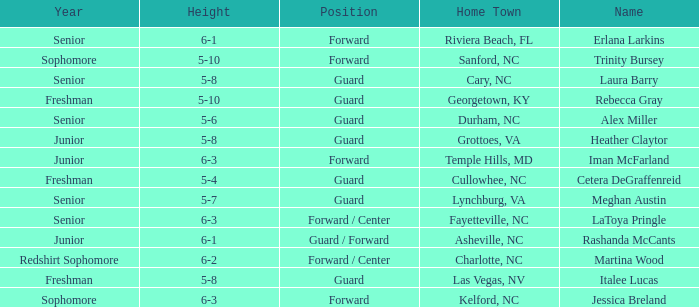What is the name of the guard from Cary, NC? Laura Barry. 